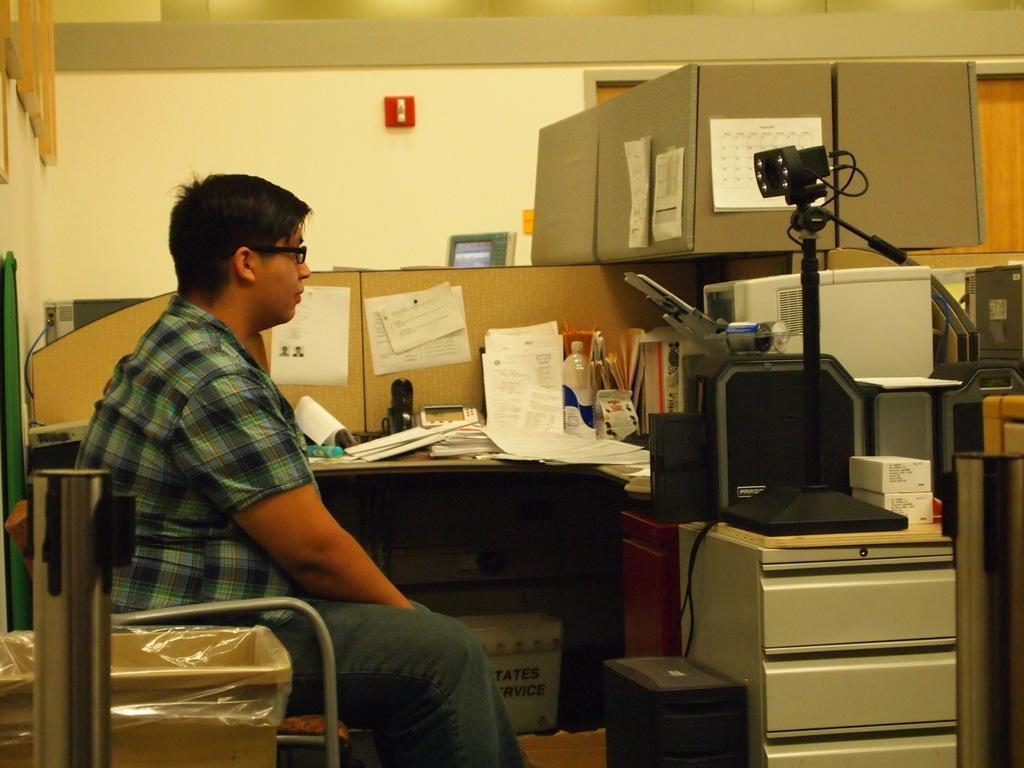Please provide a concise description of this image. In this image i can see a person sitting on a chair and an electronic device in front of him. In the background i can see few papers on the desk, a monitor, a wall and an emergency button. 